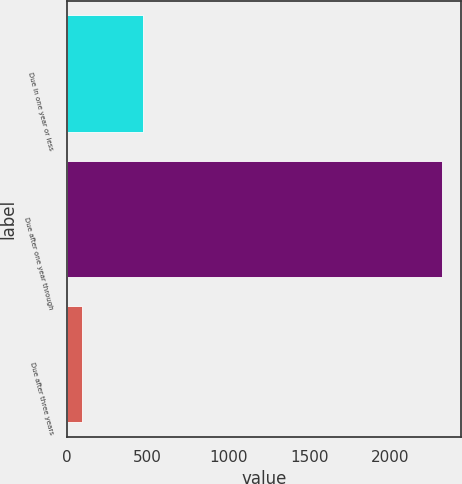Convert chart. <chart><loc_0><loc_0><loc_500><loc_500><bar_chart><fcel>Due in one year or less<fcel>Due after one year through<fcel>Due after three years<nl><fcel>470<fcel>2324<fcel>91<nl></chart> 